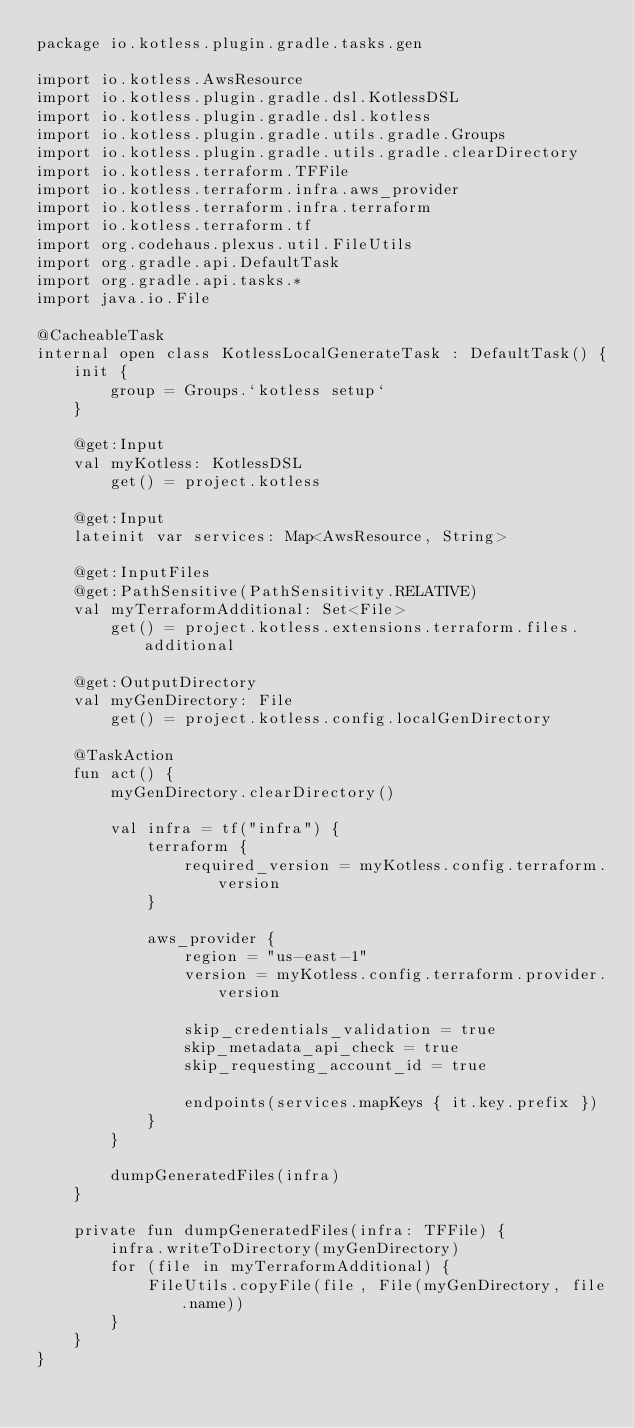Convert code to text. <code><loc_0><loc_0><loc_500><loc_500><_Kotlin_>package io.kotless.plugin.gradle.tasks.gen

import io.kotless.AwsResource
import io.kotless.plugin.gradle.dsl.KotlessDSL
import io.kotless.plugin.gradle.dsl.kotless
import io.kotless.plugin.gradle.utils.gradle.Groups
import io.kotless.plugin.gradle.utils.gradle.clearDirectory
import io.kotless.terraform.TFFile
import io.kotless.terraform.infra.aws_provider
import io.kotless.terraform.infra.terraform
import io.kotless.terraform.tf
import org.codehaus.plexus.util.FileUtils
import org.gradle.api.DefaultTask
import org.gradle.api.tasks.*
import java.io.File

@CacheableTask
internal open class KotlessLocalGenerateTask : DefaultTask() {
    init {
        group = Groups.`kotless setup`
    }

    @get:Input
    val myKotless: KotlessDSL
        get() = project.kotless

    @get:Input
    lateinit var services: Map<AwsResource, String>

    @get:InputFiles
    @get:PathSensitive(PathSensitivity.RELATIVE)
    val myTerraformAdditional: Set<File>
        get() = project.kotless.extensions.terraform.files.additional

    @get:OutputDirectory
    val myGenDirectory: File
        get() = project.kotless.config.localGenDirectory

    @TaskAction
    fun act() {
        myGenDirectory.clearDirectory()

        val infra = tf("infra") {
            terraform {
                required_version = myKotless.config.terraform.version
            }

            aws_provider {
                region = "us-east-1"
                version = myKotless.config.terraform.provider.version

                skip_credentials_validation = true
                skip_metadata_api_check = true
                skip_requesting_account_id = true

                endpoints(services.mapKeys { it.key.prefix })
            }
        }

        dumpGeneratedFiles(infra)
    }

    private fun dumpGeneratedFiles(infra: TFFile) {
        infra.writeToDirectory(myGenDirectory)
        for (file in myTerraformAdditional) {
            FileUtils.copyFile(file, File(myGenDirectory, file.name))
        }
    }
}
</code> 